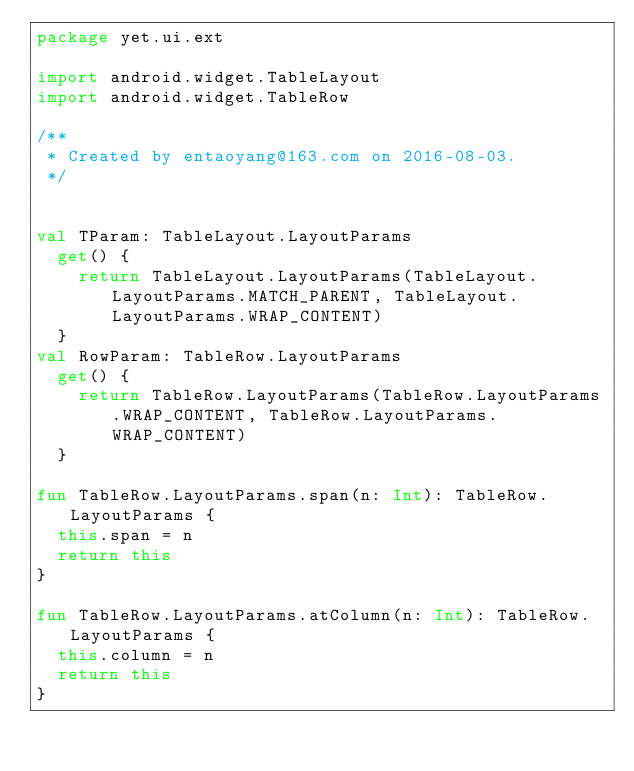Convert code to text. <code><loc_0><loc_0><loc_500><loc_500><_Kotlin_>package yet.ui.ext

import android.widget.TableLayout
import android.widget.TableRow

/**
 * Created by entaoyang@163.com on 2016-08-03.
 */


val TParam: TableLayout.LayoutParams
	get() {
		return TableLayout.LayoutParams(TableLayout.LayoutParams.MATCH_PARENT, TableLayout.LayoutParams.WRAP_CONTENT)
	}
val RowParam: TableRow.LayoutParams
	get() {
		return TableRow.LayoutParams(TableRow.LayoutParams.WRAP_CONTENT, TableRow.LayoutParams.WRAP_CONTENT)
	}

fun TableRow.LayoutParams.span(n: Int): TableRow.LayoutParams {
	this.span = n
	return this
}

fun TableRow.LayoutParams.atColumn(n: Int): TableRow.LayoutParams {
	this.column = n
	return this
}</code> 